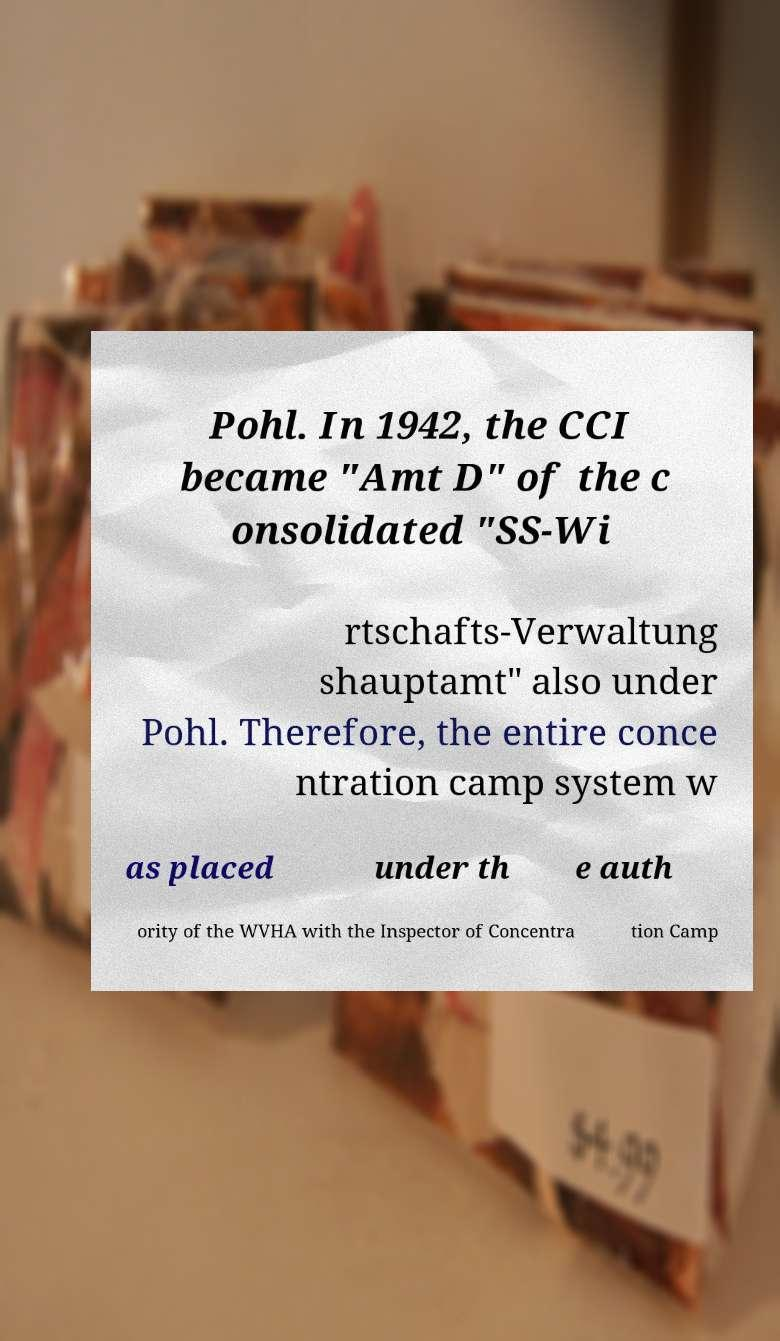Could you extract and type out the text from this image? Pohl. In 1942, the CCI became "Amt D" of the c onsolidated "SS-Wi rtschafts-Verwaltung shauptamt" also under Pohl. Therefore, the entire conce ntration camp system w as placed under th e auth ority of the WVHA with the Inspector of Concentra tion Camp 